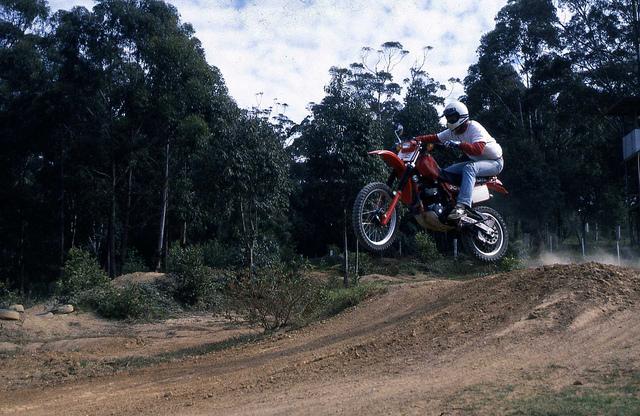Is the man trying to flee from the cops?
Quick response, please. No. What is this man riding?
Concise answer only. Motorcycle. Are there trees?
Keep it brief. Yes. What color is the rider's helmet?
Short answer required. White. How many motorcycles are there?
Concise answer only. 1. What is the speed limit?
Concise answer only. 0. 